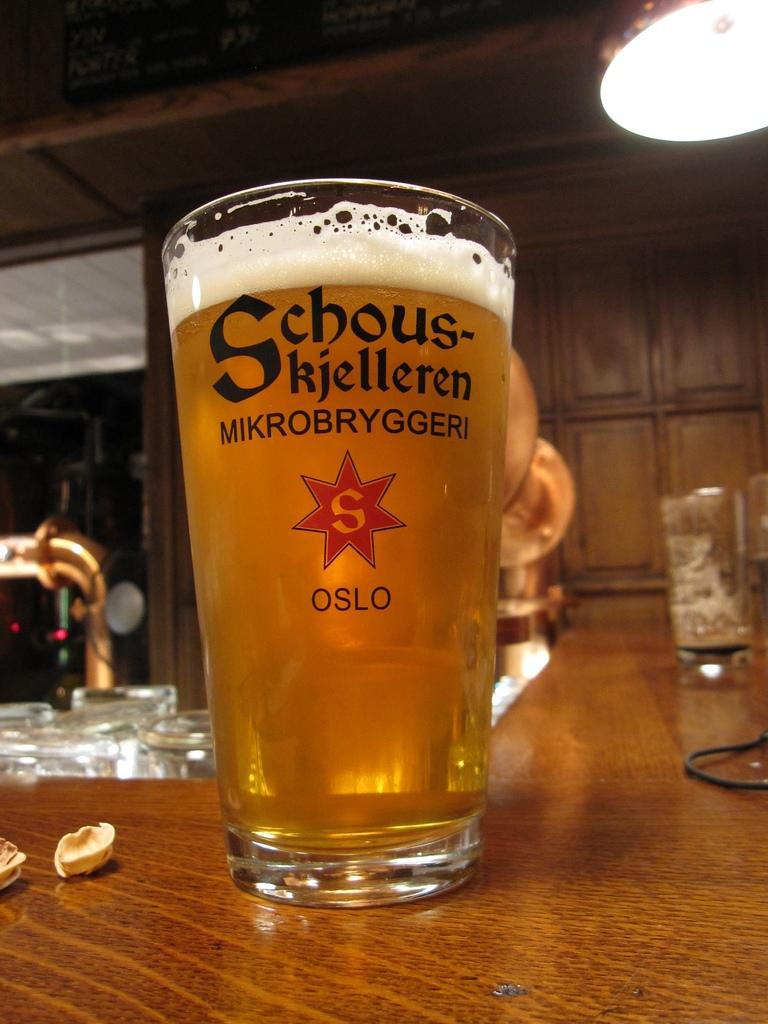<image>
Render a clear and concise summary of the photo. a tall glass of Schous-kjelleren MIKROBRYGGERI OSLO beer filled to the top. 